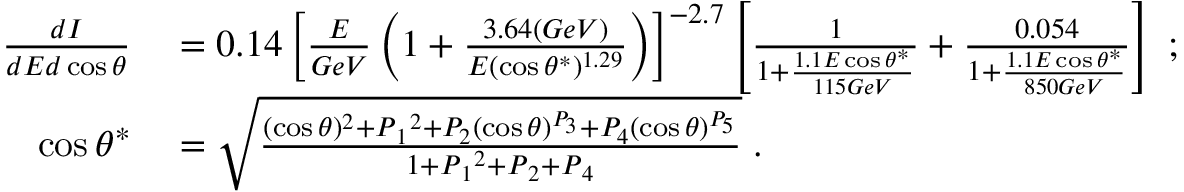Convert formula to latex. <formula><loc_0><loc_0><loc_500><loc_500>\begin{array} { r l } { \frac { d I } { d E d \cos { \theta } } } & = 0 . 1 4 \left [ \frac { E } { G e V } \left ( 1 + \frac { 3 . 6 4 ( G e V ) } { E ( \cos \theta ^ { \ast } ) ^ { 1 . 2 9 } } \right ) \right ] ^ { - 2 . 7 } \left [ \frac { 1 } { 1 + \frac { 1 . 1 E \cos \theta ^ { \ast } } { 1 1 5 G e V } } + \frac { 0 . 0 5 4 } { 1 + \frac { 1 . 1 E \cos \theta ^ { \ast } } { 8 5 0 G e V } } \right ] \, ; } \\ { \cos \theta ^ { \ast } } & = \sqrt { \frac { ( \cos \theta ) ^ { 2 } + P { _ { 1 } } ^ { 2 } + P _ { 2 } ( \cos \theta ) ^ { P _ { 3 } } + P _ { 4 } ( \cos \theta ) ^ { P _ { 5 } } } { 1 + P { _ { 1 } } ^ { 2 } + P { _ { 2 } } + P { _ { 4 } } } } \, . } \end{array}</formula> 